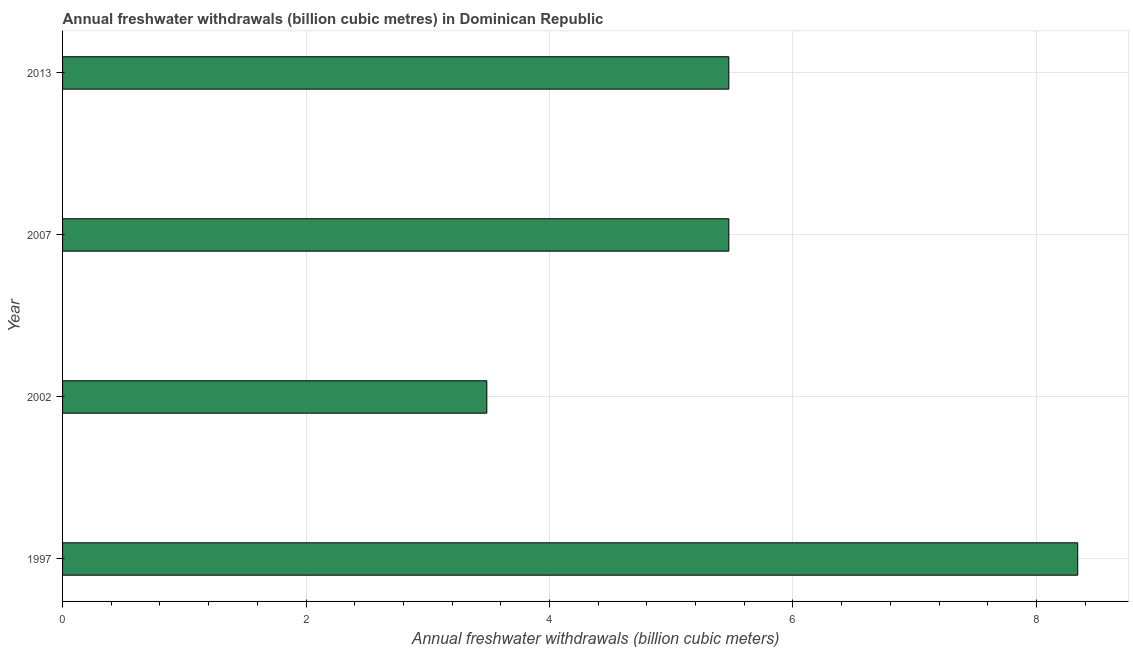Does the graph contain any zero values?
Keep it short and to the point. No. What is the title of the graph?
Offer a terse response. Annual freshwater withdrawals (billion cubic metres) in Dominican Republic. What is the label or title of the X-axis?
Give a very brief answer. Annual freshwater withdrawals (billion cubic meters). What is the annual freshwater withdrawals in 2002?
Your answer should be very brief. 3.48. Across all years, what is the maximum annual freshwater withdrawals?
Offer a terse response. 8.34. Across all years, what is the minimum annual freshwater withdrawals?
Offer a very short reply. 3.48. In which year was the annual freshwater withdrawals maximum?
Your answer should be compact. 1997. What is the sum of the annual freshwater withdrawals?
Your answer should be compact. 22.77. What is the difference between the annual freshwater withdrawals in 2007 and 2013?
Your answer should be very brief. 0. What is the average annual freshwater withdrawals per year?
Keep it short and to the point. 5.69. What is the median annual freshwater withdrawals?
Ensure brevity in your answer.  5.47. Do a majority of the years between 2002 and 2007 (inclusive) have annual freshwater withdrawals greater than 2 billion cubic meters?
Your response must be concise. Yes. What is the ratio of the annual freshwater withdrawals in 2002 to that in 2007?
Your answer should be compact. 0.64. Is the annual freshwater withdrawals in 2002 less than that in 2007?
Ensure brevity in your answer.  Yes. Is the difference between the annual freshwater withdrawals in 2002 and 2007 greater than the difference between any two years?
Give a very brief answer. No. What is the difference between the highest and the second highest annual freshwater withdrawals?
Your answer should be very brief. 2.87. What is the difference between the highest and the lowest annual freshwater withdrawals?
Provide a succinct answer. 4.85. In how many years, is the annual freshwater withdrawals greater than the average annual freshwater withdrawals taken over all years?
Make the answer very short. 1. How many bars are there?
Offer a very short reply. 4. Are all the bars in the graph horizontal?
Make the answer very short. Yes. What is the difference between two consecutive major ticks on the X-axis?
Provide a short and direct response. 2. Are the values on the major ticks of X-axis written in scientific E-notation?
Provide a succinct answer. No. What is the Annual freshwater withdrawals (billion cubic meters) of 1997?
Give a very brief answer. 8.34. What is the Annual freshwater withdrawals (billion cubic meters) of 2002?
Your answer should be compact. 3.48. What is the Annual freshwater withdrawals (billion cubic meters) of 2007?
Your answer should be very brief. 5.47. What is the Annual freshwater withdrawals (billion cubic meters) of 2013?
Offer a very short reply. 5.47. What is the difference between the Annual freshwater withdrawals (billion cubic meters) in 1997 and 2002?
Ensure brevity in your answer.  4.85. What is the difference between the Annual freshwater withdrawals (billion cubic meters) in 1997 and 2007?
Provide a succinct answer. 2.87. What is the difference between the Annual freshwater withdrawals (billion cubic meters) in 1997 and 2013?
Your response must be concise. 2.87. What is the difference between the Annual freshwater withdrawals (billion cubic meters) in 2002 and 2007?
Keep it short and to the point. -1.99. What is the difference between the Annual freshwater withdrawals (billion cubic meters) in 2002 and 2013?
Offer a very short reply. -1.99. What is the difference between the Annual freshwater withdrawals (billion cubic meters) in 2007 and 2013?
Offer a terse response. 0. What is the ratio of the Annual freshwater withdrawals (billion cubic meters) in 1997 to that in 2002?
Give a very brief answer. 2.39. What is the ratio of the Annual freshwater withdrawals (billion cubic meters) in 1997 to that in 2007?
Offer a very short reply. 1.52. What is the ratio of the Annual freshwater withdrawals (billion cubic meters) in 1997 to that in 2013?
Provide a succinct answer. 1.52. What is the ratio of the Annual freshwater withdrawals (billion cubic meters) in 2002 to that in 2007?
Give a very brief answer. 0.64. What is the ratio of the Annual freshwater withdrawals (billion cubic meters) in 2002 to that in 2013?
Your answer should be compact. 0.64. What is the ratio of the Annual freshwater withdrawals (billion cubic meters) in 2007 to that in 2013?
Your answer should be very brief. 1. 